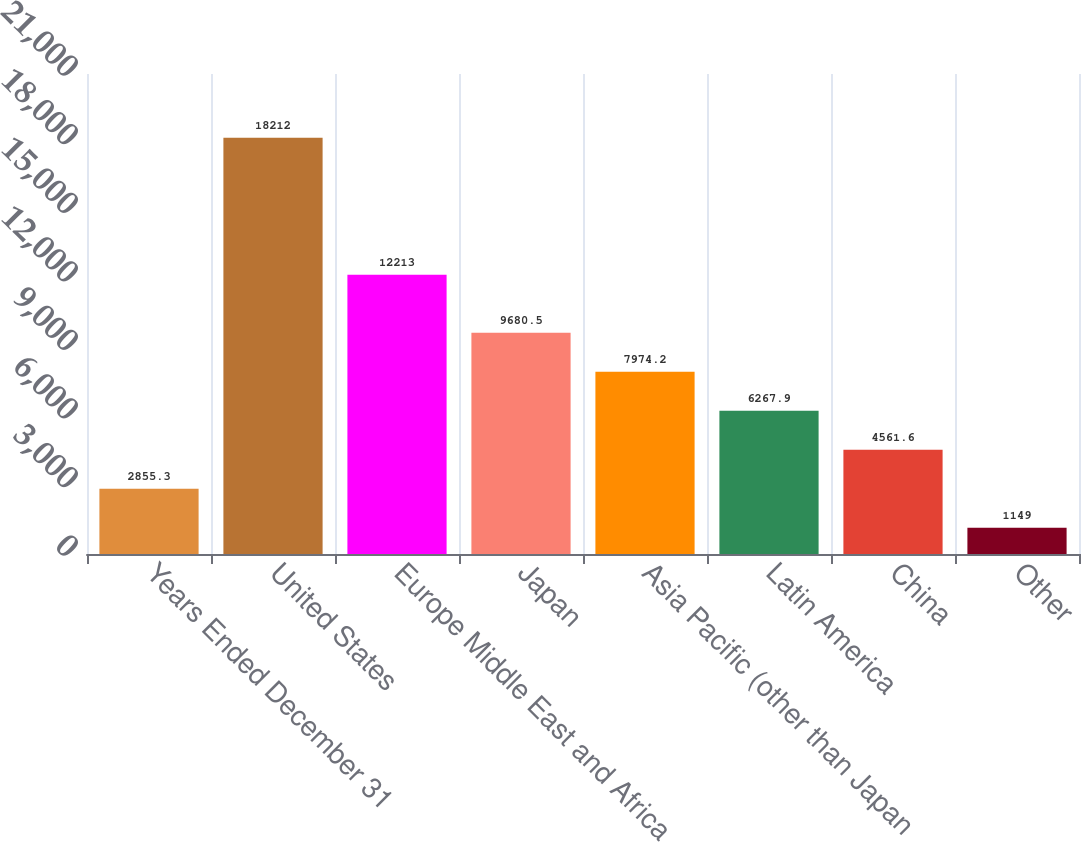Convert chart to OTSL. <chart><loc_0><loc_0><loc_500><loc_500><bar_chart><fcel>Years Ended December 31<fcel>United States<fcel>Europe Middle East and Africa<fcel>Japan<fcel>Asia Pacific (other than Japan<fcel>Latin America<fcel>China<fcel>Other<nl><fcel>2855.3<fcel>18212<fcel>12213<fcel>9680.5<fcel>7974.2<fcel>6267.9<fcel>4561.6<fcel>1149<nl></chart> 